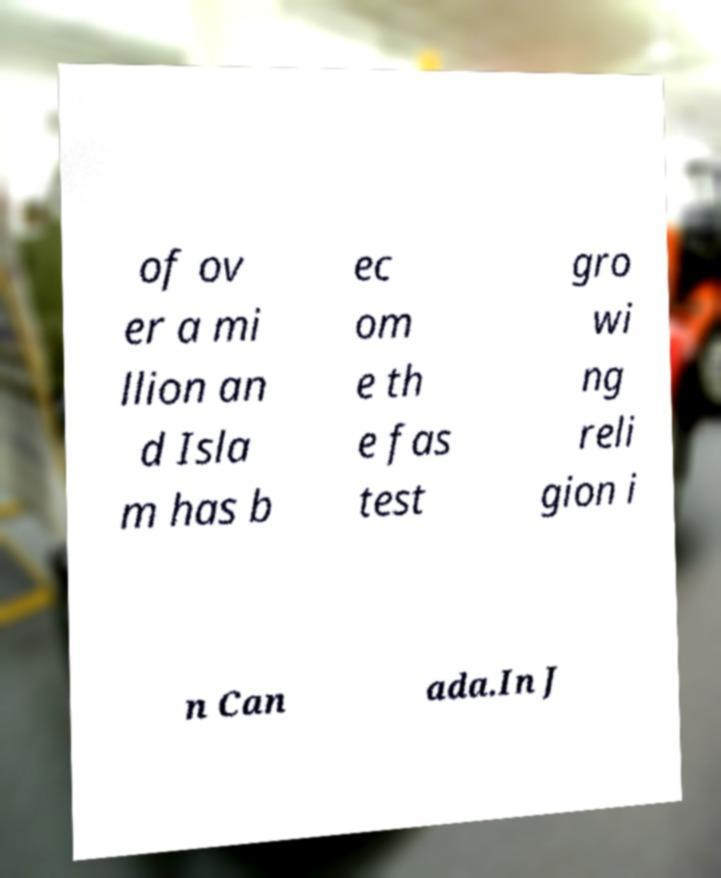Please read and relay the text visible in this image. What does it say? of ov er a mi llion an d Isla m has b ec om e th e fas test gro wi ng reli gion i n Can ada.In J 